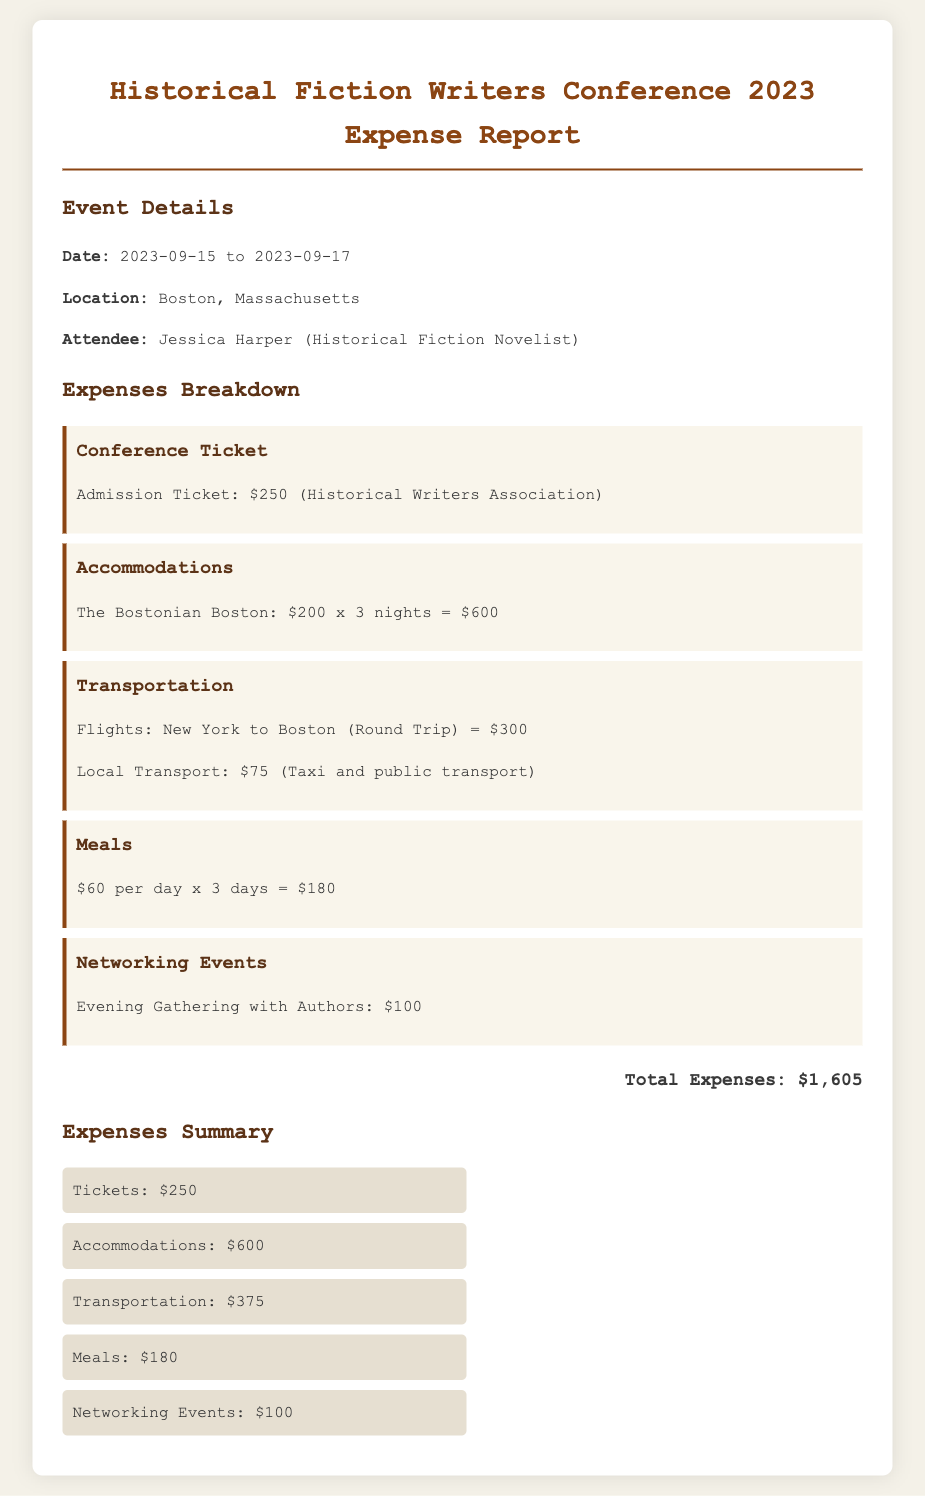What was the date of the conference? The document states that the conference took place from September 15 to September 17 in 2023.
Answer: September 15 to September 17, 2023 Who attended the event? The expense report specifies that Jessica Harper, a historical fiction novelist, attended the conference.
Answer: Jessica Harper How much was the conference ticket? The document lists the cost of the admission ticket from the Historical Writers Association as $250.
Answer: $250 What is the total amount spent on accommodations? The accommodation costs are detailed as $200 per night for 3 nights, totaling $600.
Answer: $600 What was the transportation cost for flights? The transportation section indicates that the round trip flights from New York to Boston cost $300.
Answer: $300 How much was spent on meals? The meals section notes a total cost of $180, calculated at $60 per day for three days.
Answer: $180 What is the total expense recorded in the report? The total expenses calculated in the document sum up to $1,605.
Answer: $1,605 What type of event was included in the networking costs? The networking expenses mention an evening gathering with authors, costing $100.
Answer: Evening Gathering with Authors What was the local transport cost? The document specifies that local transport costs amounted to $75.
Answer: $75 